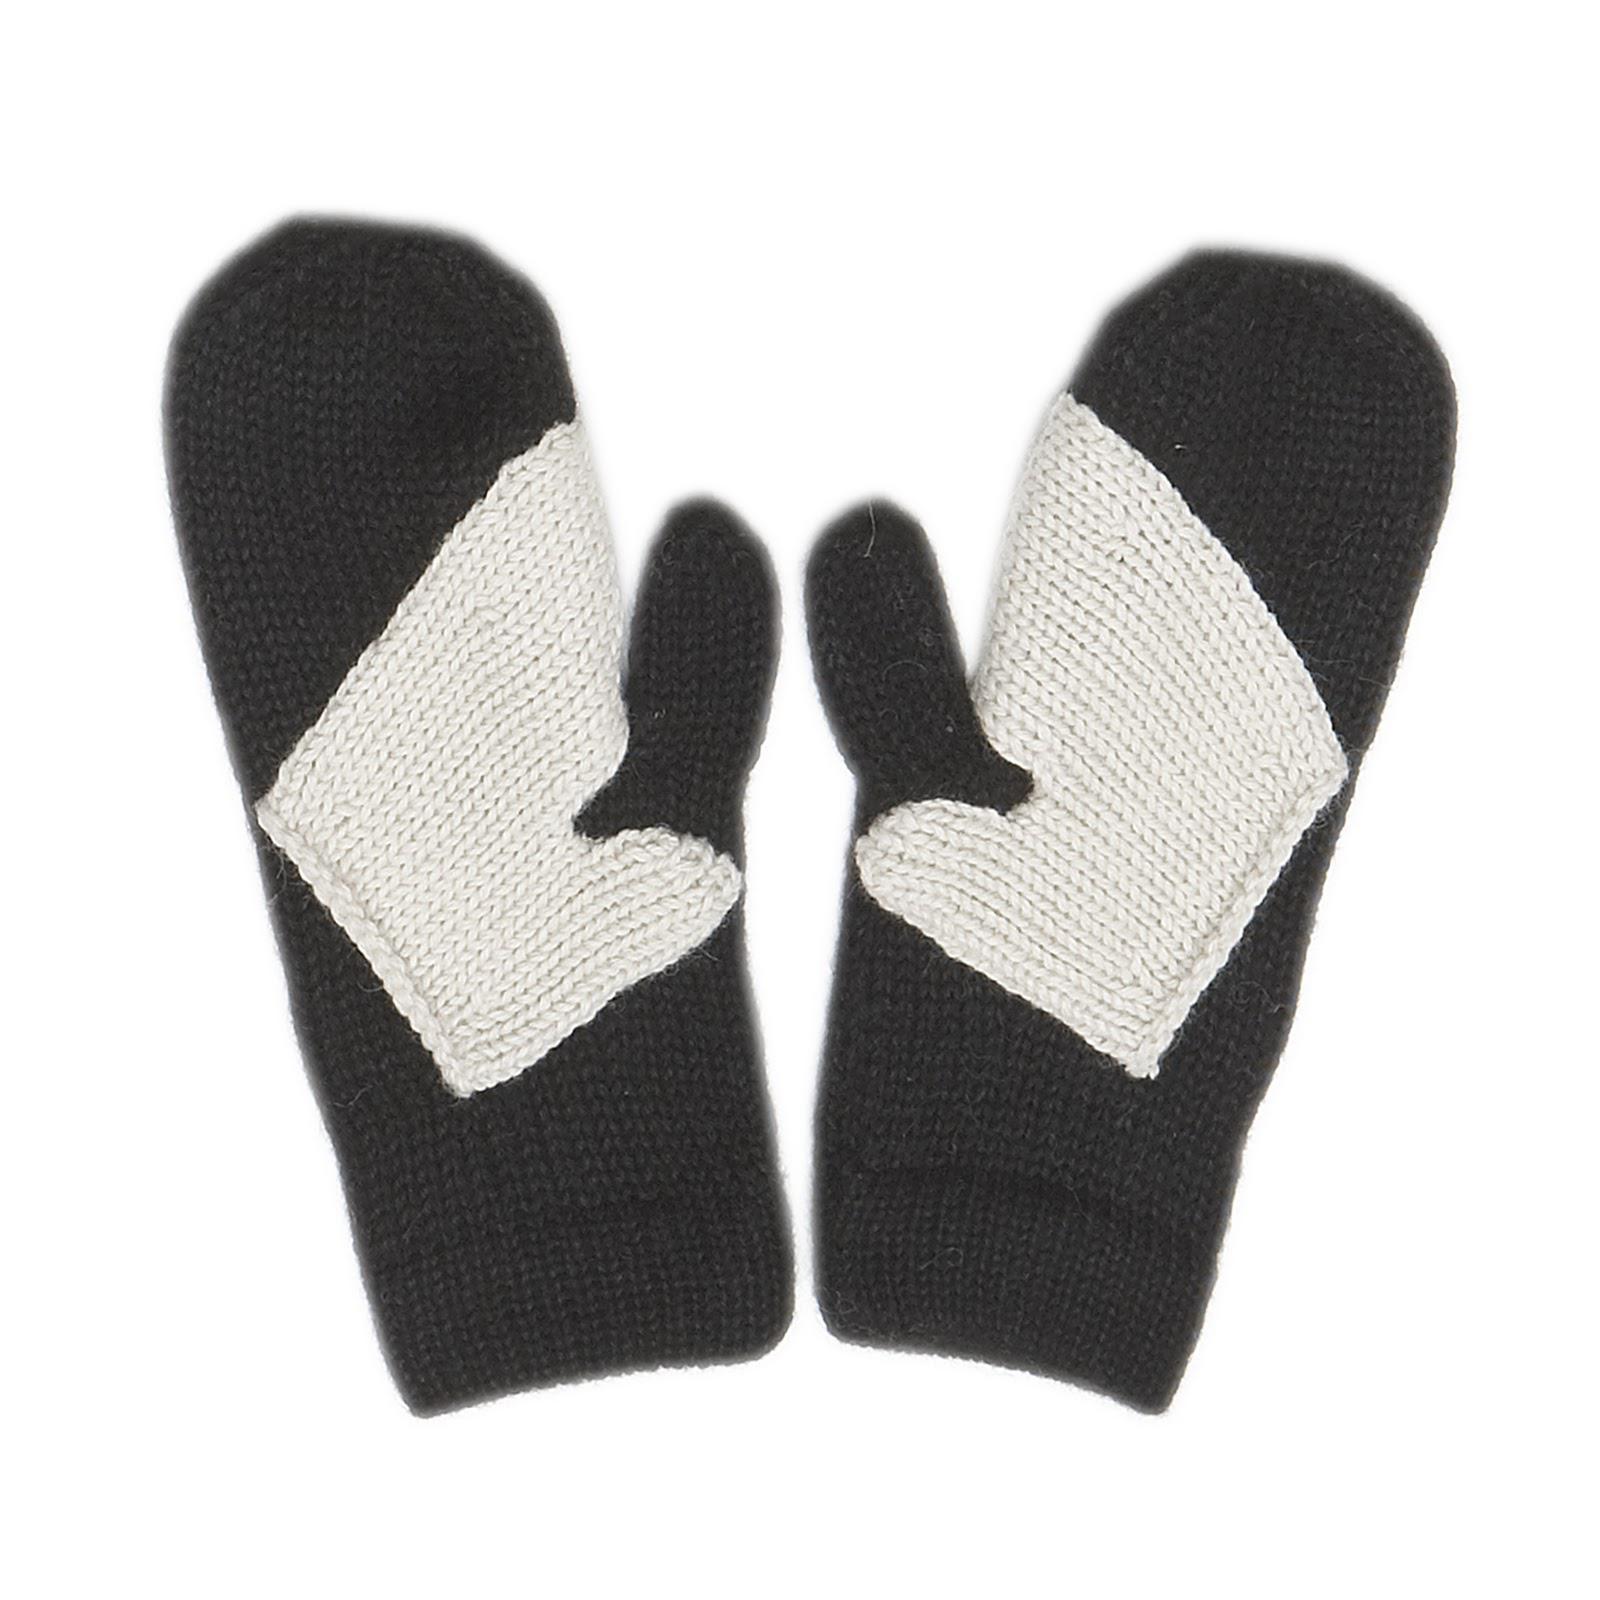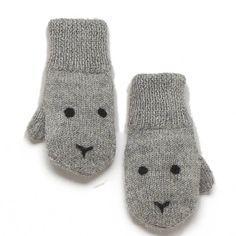The first image is the image on the left, the second image is the image on the right. For the images shown, is this caption "In one image, a pair of mittens is shown on the cover of a craft book." true? Answer yes or no. No. 